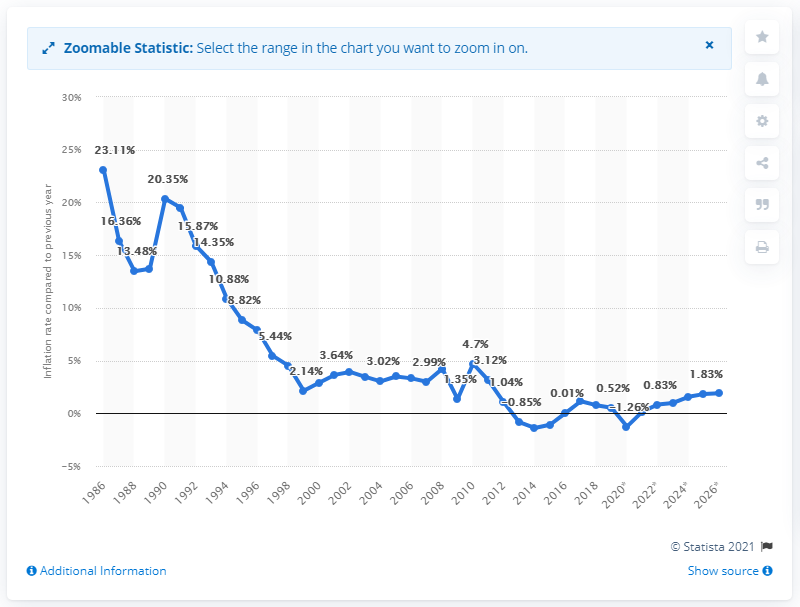List a handful of essential elements in this visual. In 2019, the inflation rate in Greece was 0.52%. In 2019, the inflation rate in India was 3.45%. 